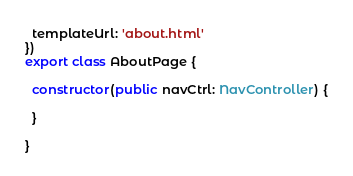Convert code to text. <code><loc_0><loc_0><loc_500><loc_500><_TypeScript_>  templateUrl: 'about.html'
})
export class AboutPage {

  constructor(public navCtrl: NavController) {

  }

}
</code> 